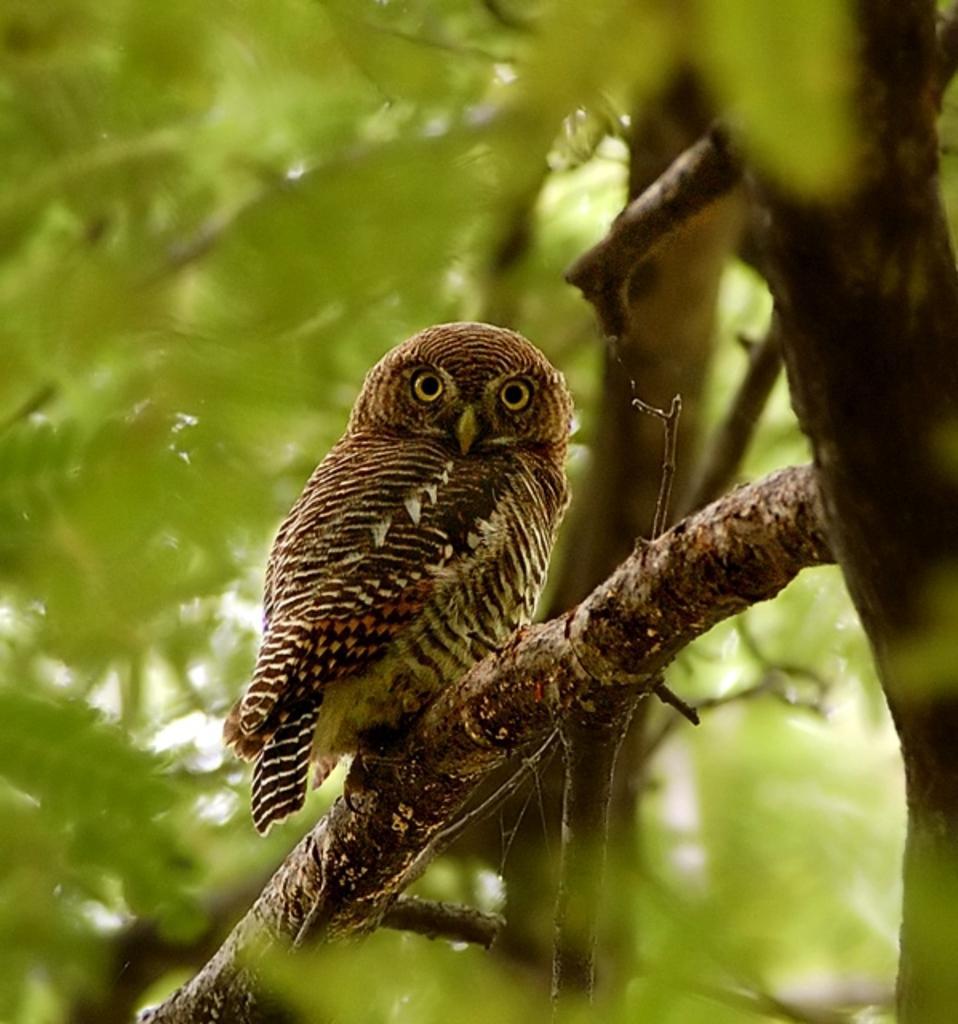Could you give a brief overview of what you see in this image? In the center of the image we can see an owl on a branch of a tree. In the background, we can see some trees. 